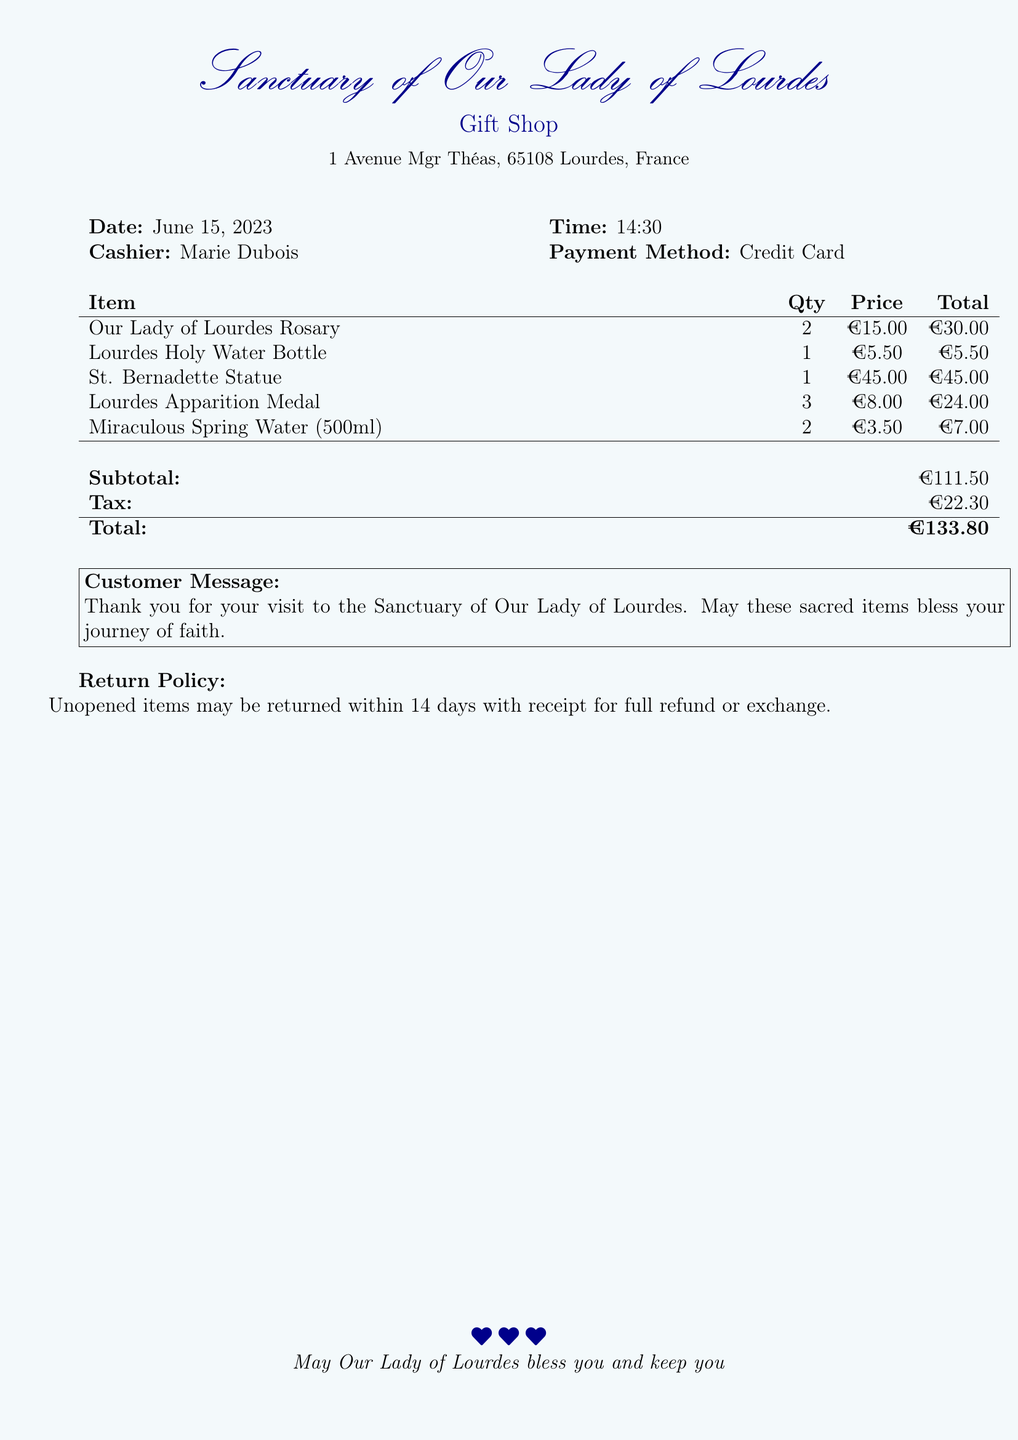what is the date of the purchase? The date of the purchase is indicated at the top of the receipt.
Answer: June 15, 2023 who was the cashier? The cashier's name is listed beside the date on the receipt.
Answer: Marie Dubois what item had the highest price? The item with the highest price can be identified in the itemized list.
Answer: St. Bernadette Statue how many Lourdes Apparition Medals were purchased? The quantity for the Lourdes Apparition Medal is specified in the itemized list.
Answer: 3 what is the subtotal amount before tax? The subtotal amount can be found in the summary section of the receipt.
Answer: €111.50 what is the total amount after tax? The total amount is provided at the end of the receipt.
Answer: €133.80 what is the return policy duration? The return policy duration is stated in the document under the return policy section.
Answer: 14 days what type of payment was used? The payment method is listed in the purchase details.
Answer: Credit Card 